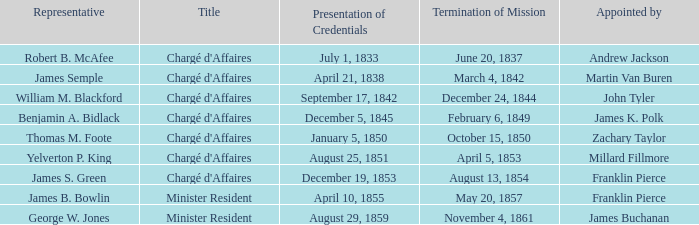What Representative has a Presentation of Credentails of April 10, 1855? James B. Bowlin. 